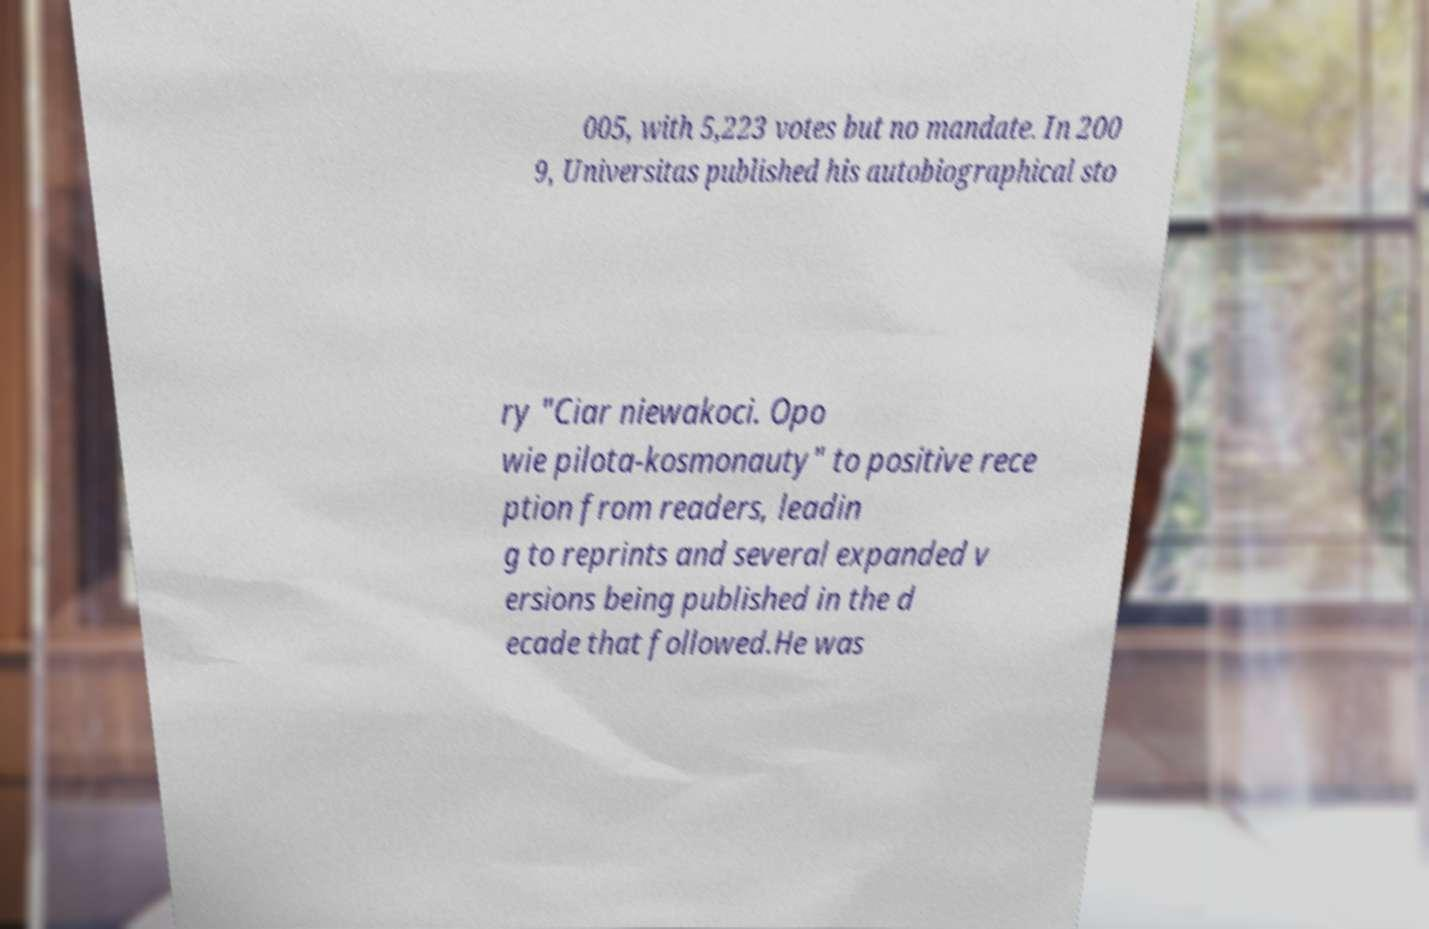Could you extract and type out the text from this image? 005, with 5,223 votes but no mandate. In 200 9, Universitas published his autobiographical sto ry "Ciar niewakoci. Opo wie pilota-kosmonauty" to positive rece ption from readers, leadin g to reprints and several expanded v ersions being published in the d ecade that followed.He was 